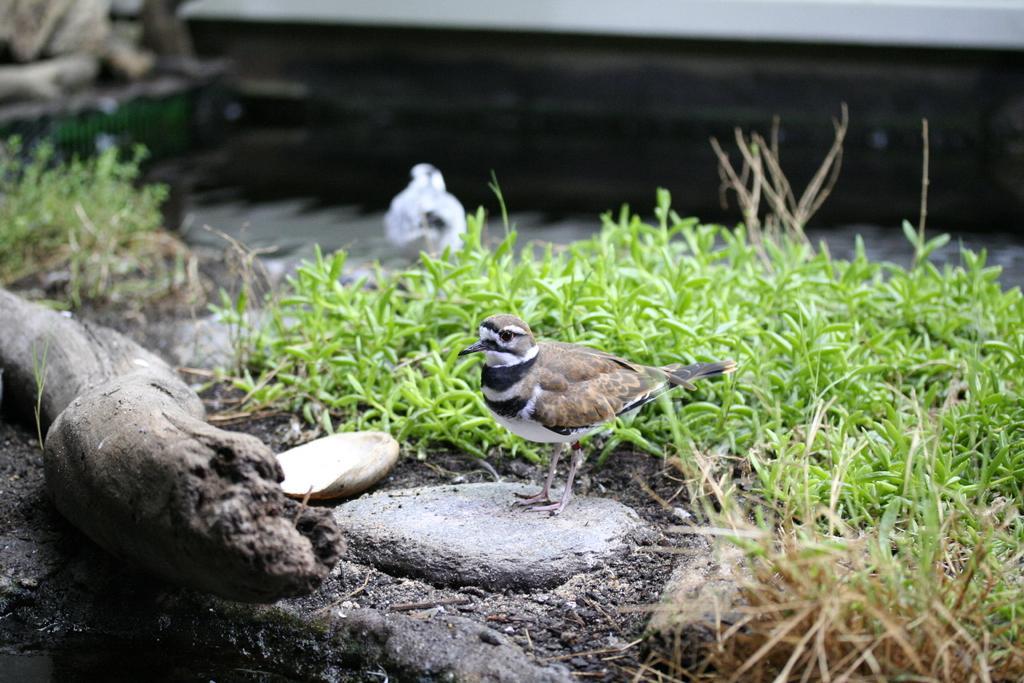Could you give a brief overview of what you see in this image? In this image in the center there is one bird, at the bottom there is some grass and in the background there is another bird and some objects. 